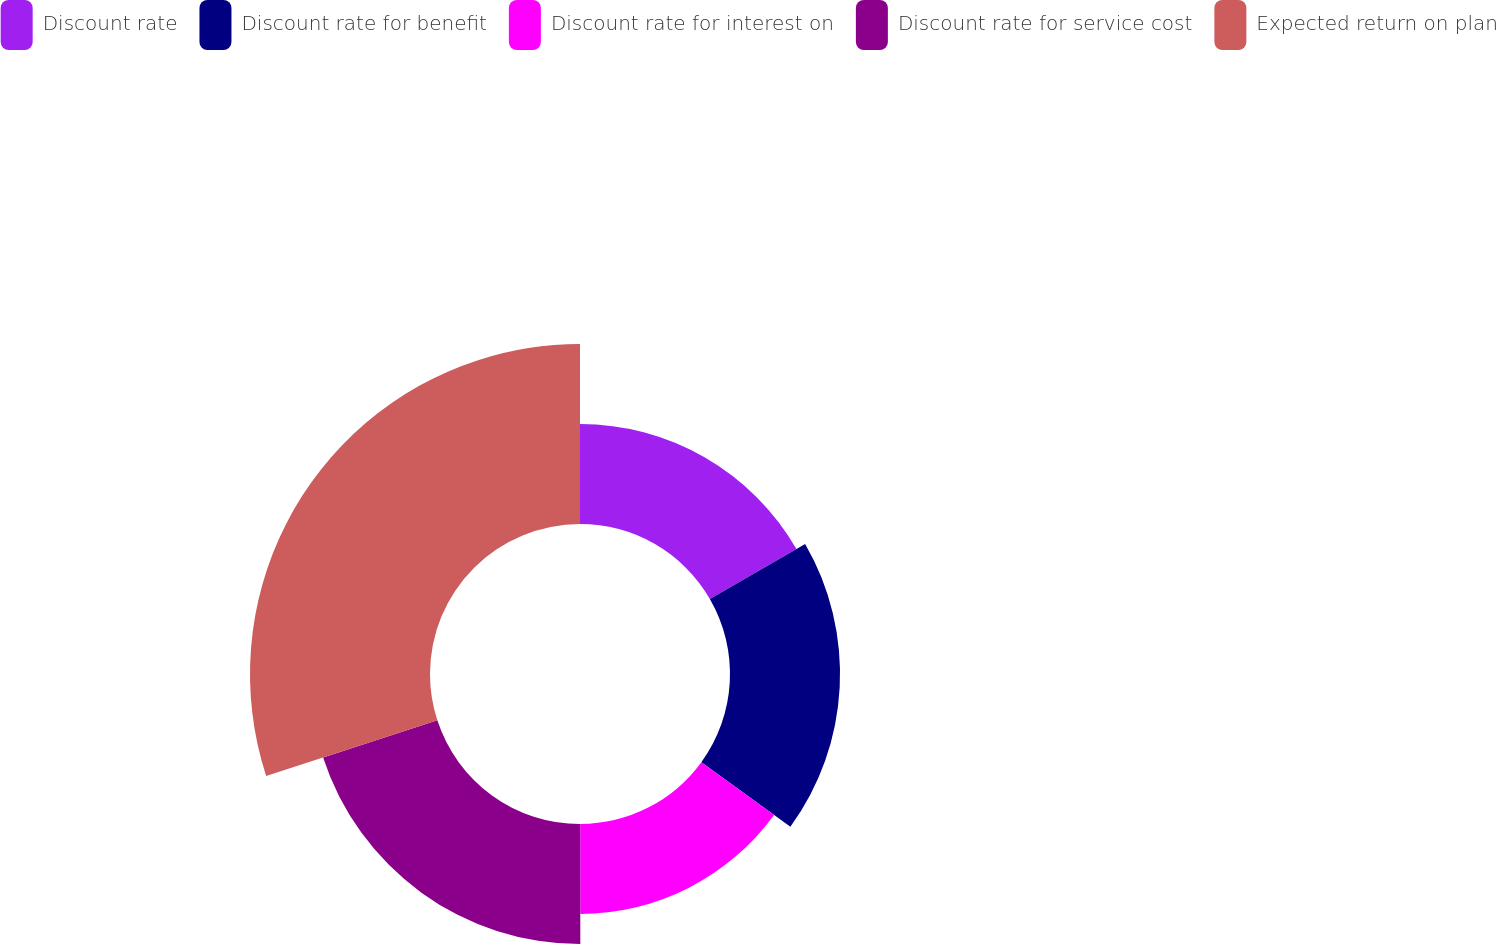Convert chart to OTSL. <chart><loc_0><loc_0><loc_500><loc_500><pie_chart><fcel>Discount rate<fcel>Discount rate for benefit<fcel>Discount rate for interest on<fcel>Discount rate for service cost<fcel>Expected return on plan<nl><fcel>16.66%<fcel>18.34%<fcel>14.98%<fcel>20.02%<fcel>30.0%<nl></chart> 